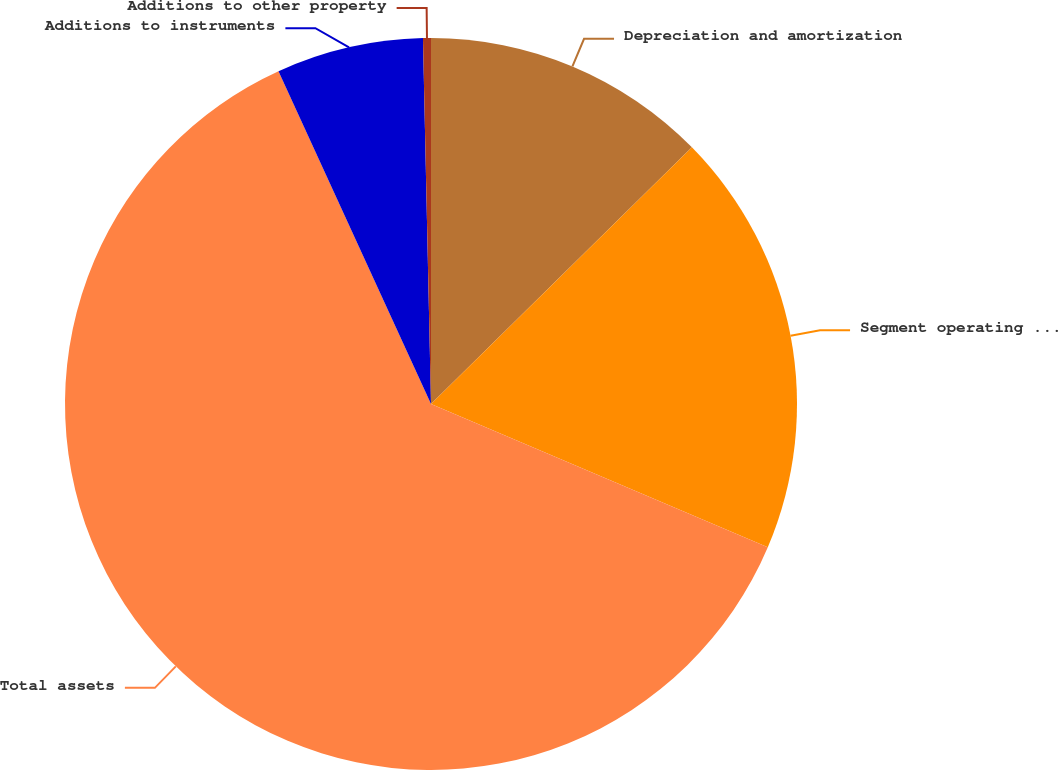<chart> <loc_0><loc_0><loc_500><loc_500><pie_chart><fcel>Depreciation and amortization<fcel>Segment operating profit<fcel>Total assets<fcel>Additions to instruments<fcel>Additions to other property<nl><fcel>12.63%<fcel>18.77%<fcel>61.76%<fcel>6.49%<fcel>0.35%<nl></chart> 